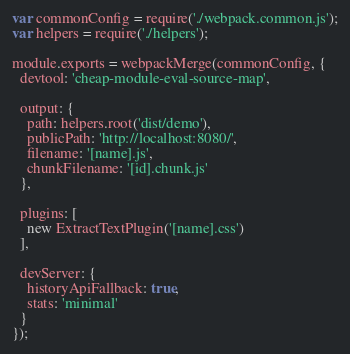Convert code to text. <code><loc_0><loc_0><loc_500><loc_500><_JavaScript_>var commonConfig = require('./webpack.common.js');
var helpers = require('./helpers');

module.exports = webpackMerge(commonConfig, {
  devtool: 'cheap-module-eval-source-map',

  output: {
    path: helpers.root('dist/demo'),
    publicPath: 'http://localhost:8080/',
    filename: '[name].js',
    chunkFilename: '[id].chunk.js'
  },

  plugins: [
    new ExtractTextPlugin('[name].css')
  ],

  devServer: {
    historyApiFallback: true,
    stats: 'minimal'
  }
});
</code> 